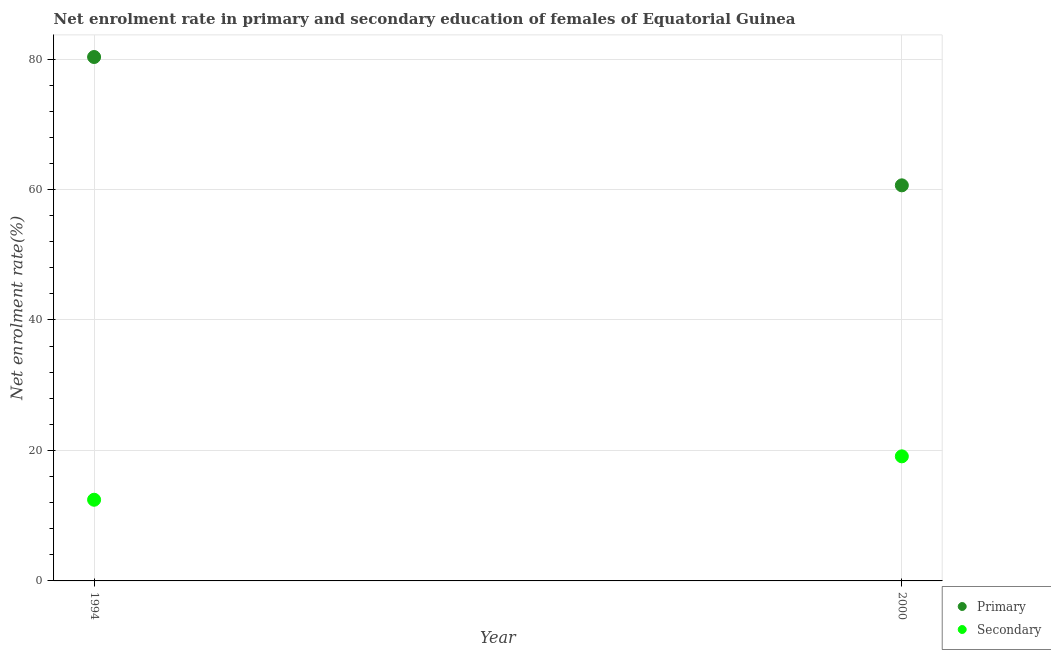Is the number of dotlines equal to the number of legend labels?
Your answer should be very brief. Yes. What is the enrollment rate in primary education in 1994?
Ensure brevity in your answer.  80.31. Across all years, what is the maximum enrollment rate in primary education?
Keep it short and to the point. 80.31. Across all years, what is the minimum enrollment rate in primary education?
Make the answer very short. 60.64. What is the total enrollment rate in primary education in the graph?
Make the answer very short. 140.95. What is the difference between the enrollment rate in secondary education in 1994 and that in 2000?
Offer a very short reply. -6.65. What is the difference between the enrollment rate in primary education in 1994 and the enrollment rate in secondary education in 2000?
Give a very brief answer. 61.21. What is the average enrollment rate in secondary education per year?
Your answer should be compact. 15.77. In the year 2000, what is the difference between the enrollment rate in primary education and enrollment rate in secondary education?
Give a very brief answer. 41.54. In how many years, is the enrollment rate in primary education greater than 44 %?
Keep it short and to the point. 2. What is the ratio of the enrollment rate in secondary education in 1994 to that in 2000?
Your answer should be very brief. 0.65. Is the enrollment rate in secondary education in 1994 less than that in 2000?
Make the answer very short. Yes. In how many years, is the enrollment rate in primary education greater than the average enrollment rate in primary education taken over all years?
Your answer should be very brief. 1. Does the enrollment rate in primary education monotonically increase over the years?
Keep it short and to the point. No. Is the enrollment rate in secondary education strictly greater than the enrollment rate in primary education over the years?
Provide a short and direct response. No. How many dotlines are there?
Ensure brevity in your answer.  2. How many years are there in the graph?
Offer a terse response. 2. What is the difference between two consecutive major ticks on the Y-axis?
Provide a succinct answer. 20. Are the values on the major ticks of Y-axis written in scientific E-notation?
Provide a short and direct response. No. How many legend labels are there?
Provide a short and direct response. 2. How are the legend labels stacked?
Provide a short and direct response. Vertical. What is the title of the graph?
Provide a succinct answer. Net enrolment rate in primary and secondary education of females of Equatorial Guinea. Does "RDB concessional" appear as one of the legend labels in the graph?
Your answer should be very brief. No. What is the label or title of the X-axis?
Your response must be concise. Year. What is the label or title of the Y-axis?
Keep it short and to the point. Net enrolment rate(%). What is the Net enrolment rate(%) of Primary in 1994?
Your response must be concise. 80.31. What is the Net enrolment rate(%) in Secondary in 1994?
Your answer should be very brief. 12.44. What is the Net enrolment rate(%) in Primary in 2000?
Your answer should be compact. 60.64. What is the Net enrolment rate(%) in Secondary in 2000?
Keep it short and to the point. 19.1. Across all years, what is the maximum Net enrolment rate(%) in Primary?
Keep it short and to the point. 80.31. Across all years, what is the maximum Net enrolment rate(%) in Secondary?
Make the answer very short. 19.1. Across all years, what is the minimum Net enrolment rate(%) in Primary?
Make the answer very short. 60.64. Across all years, what is the minimum Net enrolment rate(%) in Secondary?
Offer a very short reply. 12.44. What is the total Net enrolment rate(%) of Primary in the graph?
Keep it short and to the point. 140.95. What is the total Net enrolment rate(%) of Secondary in the graph?
Make the answer very short. 31.54. What is the difference between the Net enrolment rate(%) in Primary in 1994 and that in 2000?
Keep it short and to the point. 19.67. What is the difference between the Net enrolment rate(%) in Secondary in 1994 and that in 2000?
Your response must be concise. -6.65. What is the difference between the Net enrolment rate(%) in Primary in 1994 and the Net enrolment rate(%) in Secondary in 2000?
Give a very brief answer. 61.21. What is the average Net enrolment rate(%) of Primary per year?
Ensure brevity in your answer.  70.47. What is the average Net enrolment rate(%) in Secondary per year?
Offer a very short reply. 15.77. In the year 1994, what is the difference between the Net enrolment rate(%) of Primary and Net enrolment rate(%) of Secondary?
Your response must be concise. 67.87. In the year 2000, what is the difference between the Net enrolment rate(%) of Primary and Net enrolment rate(%) of Secondary?
Offer a very short reply. 41.54. What is the ratio of the Net enrolment rate(%) of Primary in 1994 to that in 2000?
Offer a terse response. 1.32. What is the ratio of the Net enrolment rate(%) of Secondary in 1994 to that in 2000?
Your response must be concise. 0.65. What is the difference between the highest and the second highest Net enrolment rate(%) of Primary?
Offer a very short reply. 19.67. What is the difference between the highest and the second highest Net enrolment rate(%) in Secondary?
Offer a very short reply. 6.65. What is the difference between the highest and the lowest Net enrolment rate(%) of Primary?
Keep it short and to the point. 19.67. What is the difference between the highest and the lowest Net enrolment rate(%) in Secondary?
Give a very brief answer. 6.65. 